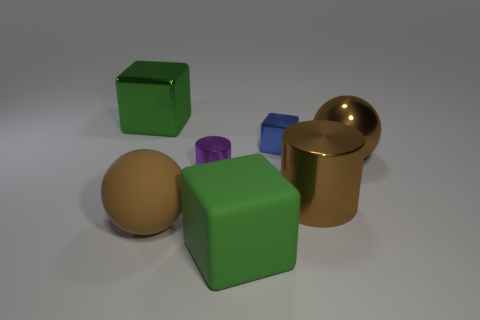What number of cyan objects are either tiny cubes or big rubber things?
Keep it short and to the point. 0. What is the color of the large matte ball?
Provide a succinct answer. Brown. What is the size of the ball that is made of the same material as the purple thing?
Ensure brevity in your answer.  Large. What number of blue objects are the same shape as the big green rubber object?
Your answer should be very brief. 1. Are there any other things that have the same size as the green shiny cube?
Offer a very short reply. Yes. What is the size of the brown metal thing that is to the left of the metallic ball right of the blue metallic cube?
Provide a succinct answer. Large. There is a blue object that is the same size as the purple cylinder; what is it made of?
Provide a succinct answer. Metal. Are there any big cyan objects that have the same material as the small block?
Your response must be concise. No. There is a big rubber object to the left of the big green rubber object that is right of the ball in front of the big brown shiny sphere; what color is it?
Your response must be concise. Brown. Does the tiny object behind the small purple metal cylinder have the same color as the big thing that is behind the tiny shiny block?
Keep it short and to the point. No. 